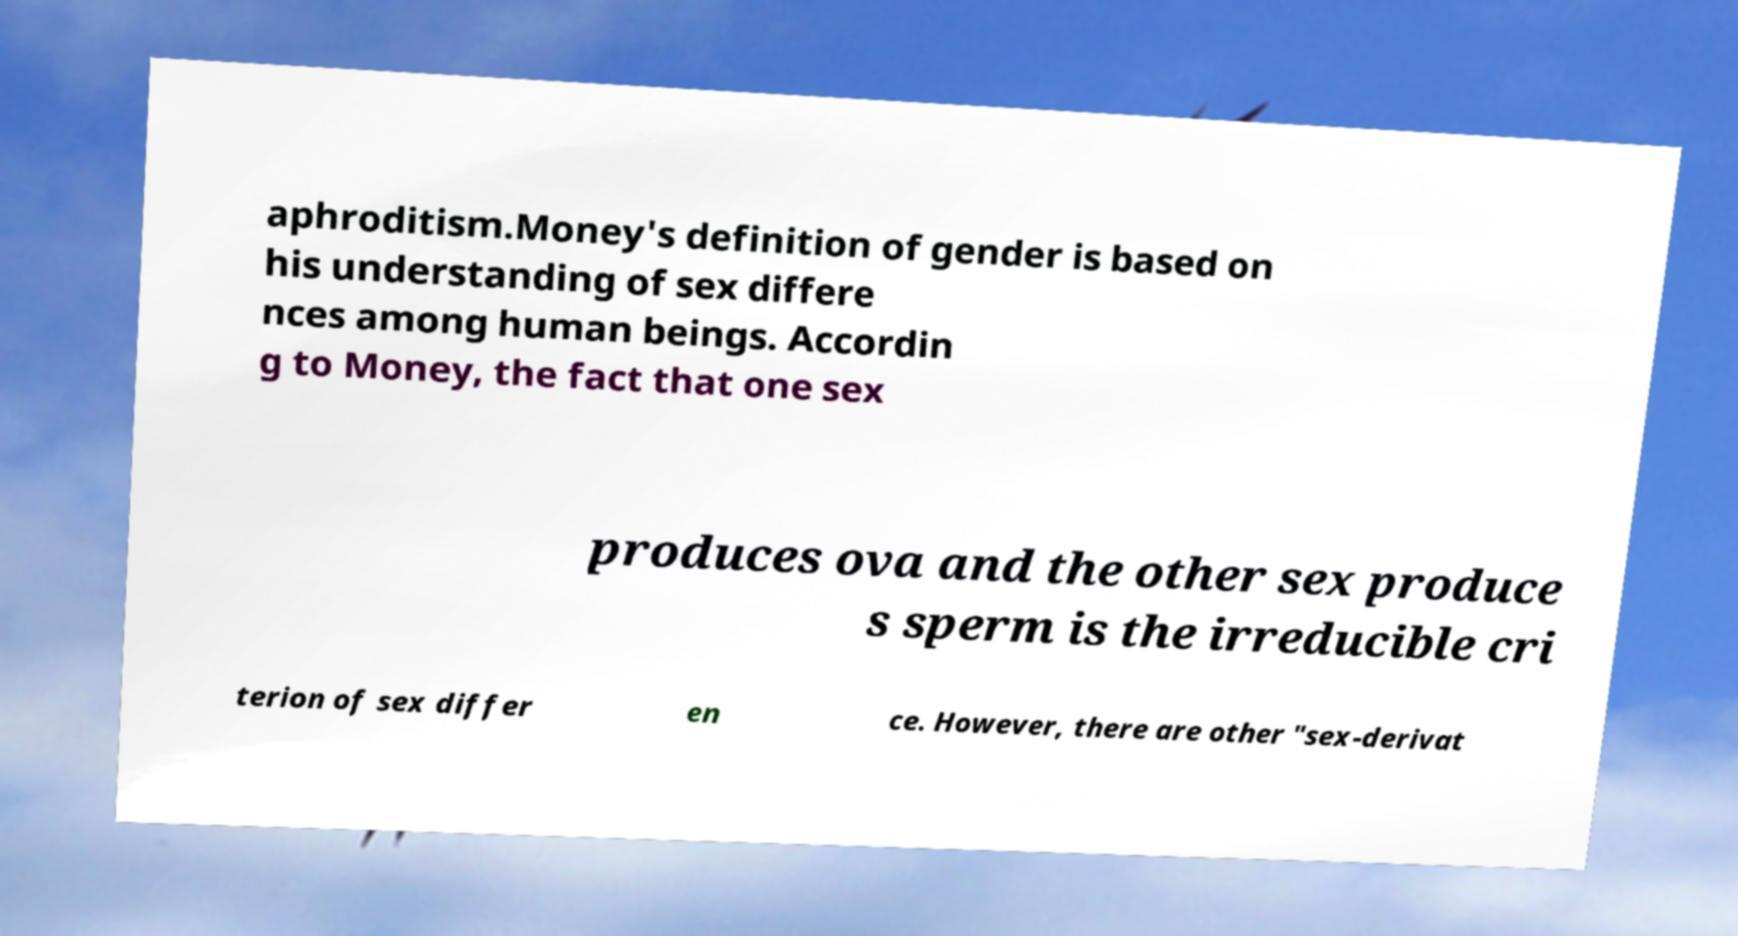Can you read and provide the text displayed in the image?This photo seems to have some interesting text. Can you extract and type it out for me? aphroditism.Money's definition of gender is based on his understanding of sex differe nces among human beings. Accordin g to Money, the fact that one sex produces ova and the other sex produce s sperm is the irreducible cri terion of sex differ en ce. However, there are other "sex-derivat 